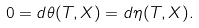Convert formula to latex. <formula><loc_0><loc_0><loc_500><loc_500>0 = d \theta ( T , X ) = d \eta ( T , X ) .</formula> 